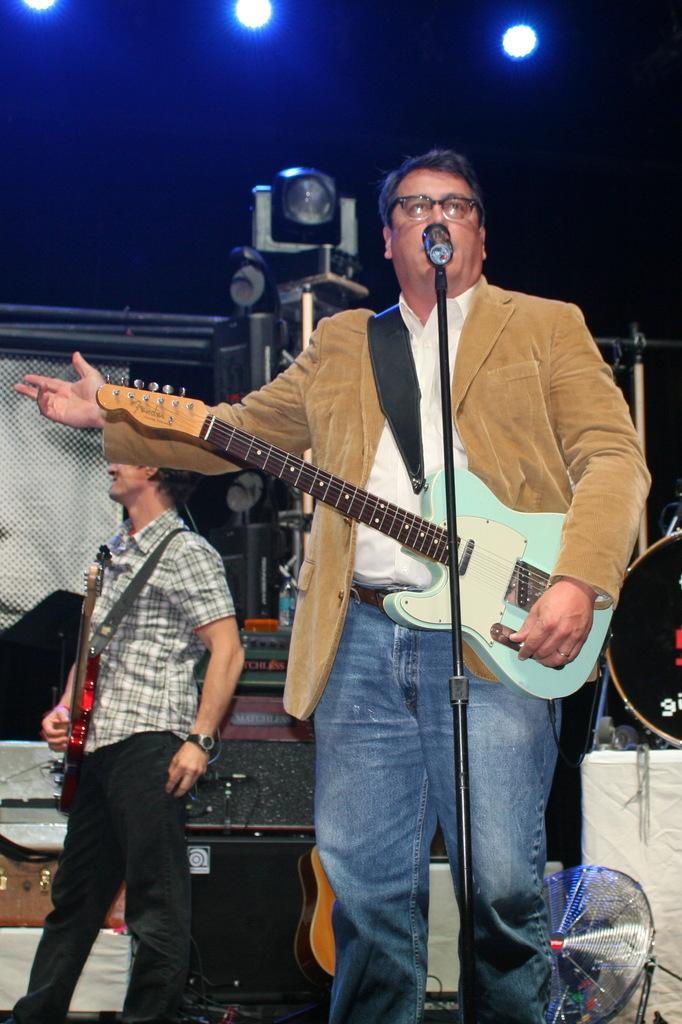Can you describe this image briefly? To the front there is a man with brown jacket, white shirt and jeans. He is playing guitar. In front of him there is a mic. To the left side there is a man with black checks shirt and holding a guitar in his hand. In the background there are lights and a black box. To the bottom right there is a fan. 